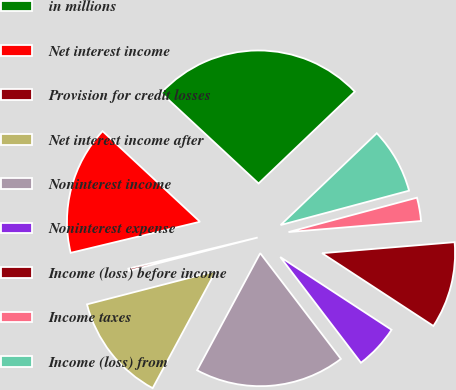<chart> <loc_0><loc_0><loc_500><loc_500><pie_chart><fcel>in millions<fcel>Net interest income<fcel>Provision for credit losses<fcel>Net interest income after<fcel>Noninterest income<fcel>Noninterest expense<fcel>Income (loss) before income<fcel>Income taxes<fcel>Income (loss) from<nl><fcel>25.95%<fcel>15.68%<fcel>0.27%<fcel>13.11%<fcel>18.24%<fcel>5.41%<fcel>10.54%<fcel>2.84%<fcel>7.97%<nl></chart> 